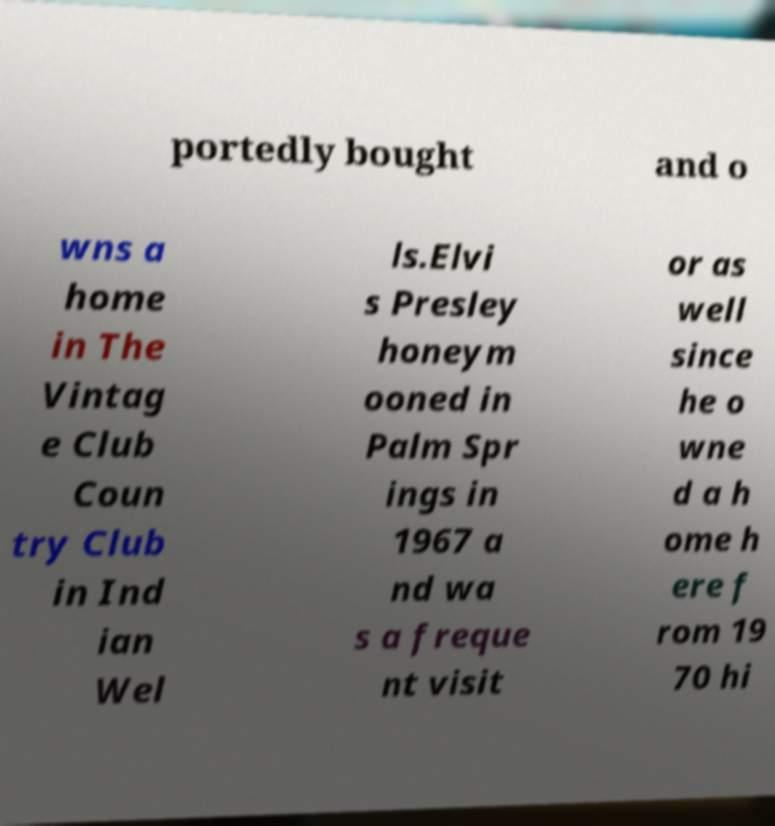I need the written content from this picture converted into text. Can you do that? portedly bought and o wns a home in The Vintag e Club Coun try Club in Ind ian Wel ls.Elvi s Presley honeym ooned in Palm Spr ings in 1967 a nd wa s a freque nt visit or as well since he o wne d a h ome h ere f rom 19 70 hi 